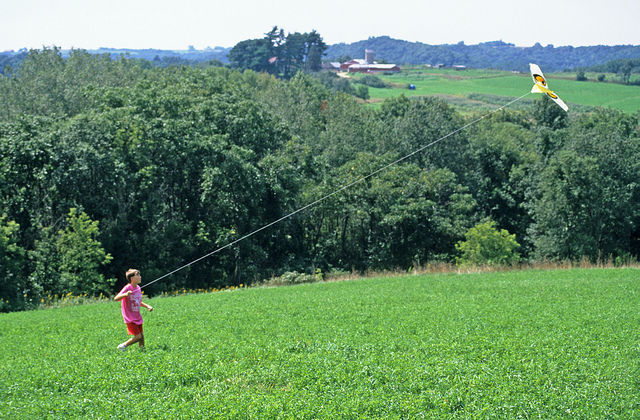What else can the child do in such a location besides flying a kite? Besides flying a kite, the child could enjoy a variety of outdoor activities in the lush, open landscape. They could have a picnic amidst the grass, play games like tag or Frisbee, explore the nearby wooded areas for wildlife, or simply sit and read a book surrounded by nature’s tranquility. The open meadow and peaceful surroundings offer endless opportunities for creativity and fun. 